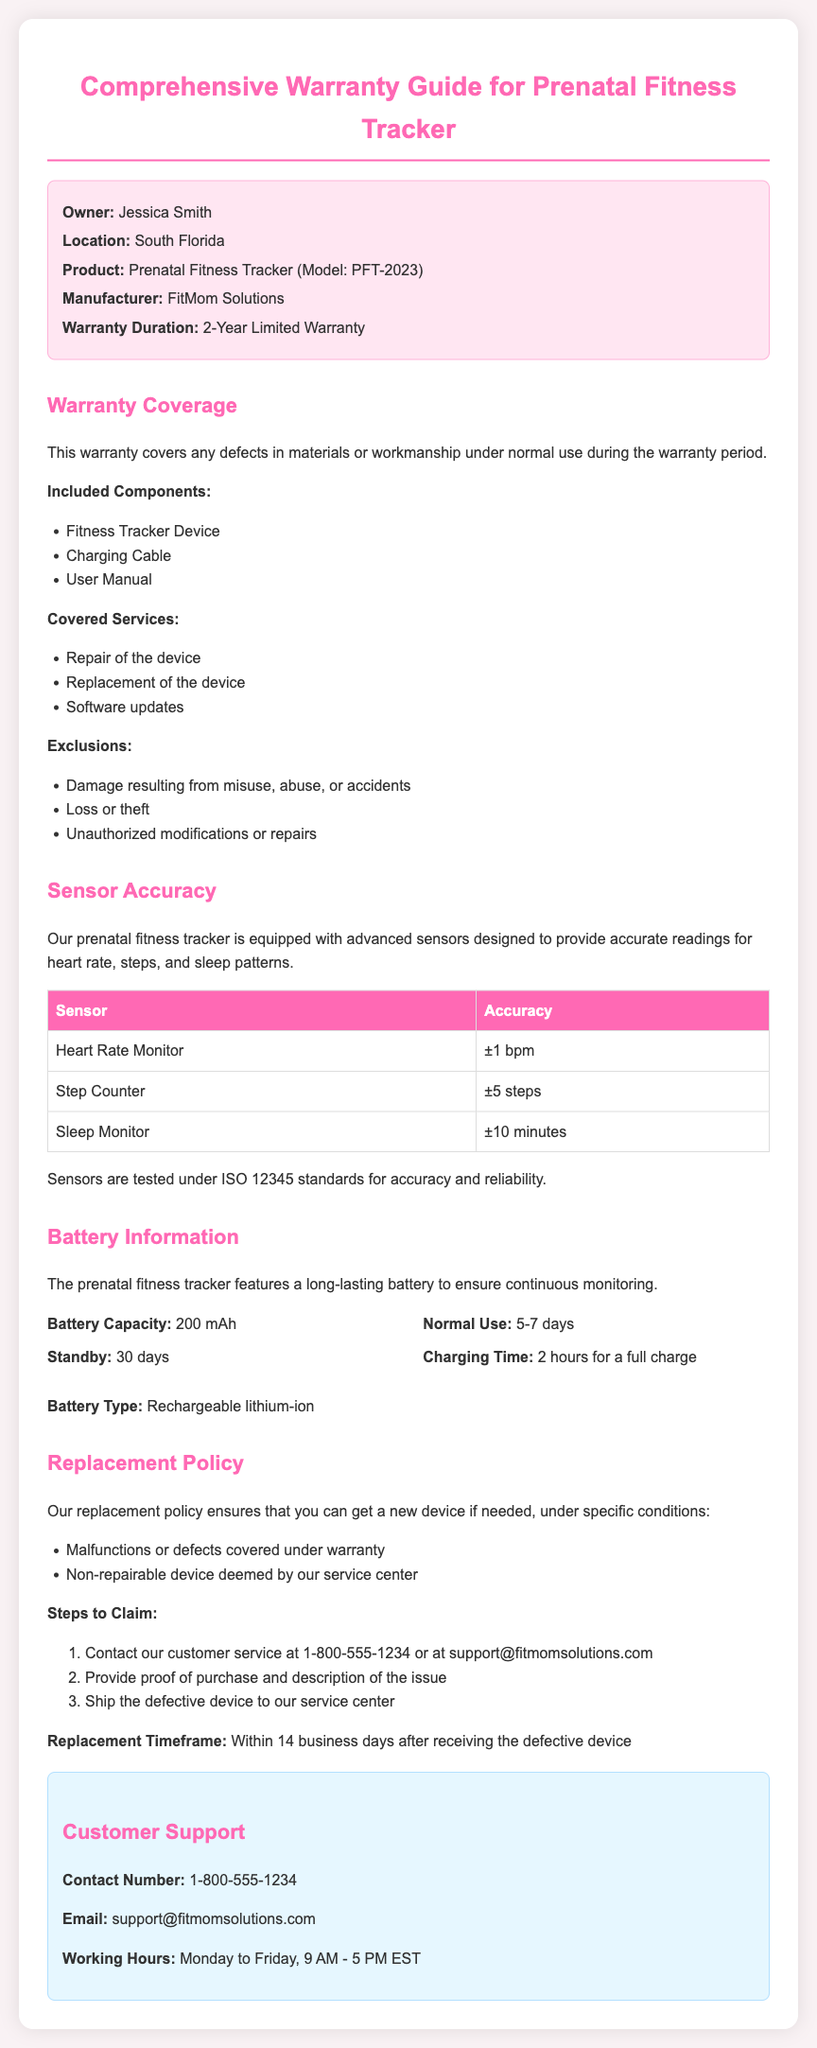What is the warranty duration? The warranty duration is stated clearly in the document as two years.
Answer: 2-Year Limited Warranty What is the battery capacity? The document specifies the battery capacity for the prenatal fitness tracker.
Answer: 200 mAh What is the accuracy of the heart rate monitor? The accuracy for the heart rate monitor is provided in the sensor accuracy table.
Answer: ±1 bpm What must be provided to claim a replacement? The document lists the required information for claiming a replacement.
Answer: Proof of purchase What are the normal use days for the battery? The battery information section indicates how long the device lasts under normal use.
Answer: 5-7 days What services are covered under the warranty? The covered services are listed in the warranty coverage section of the document.
Answer: Repair of the device What is the replacement timeframe? The timeframe for replacement after sending in a defective device is mentioned in the document.
Answer: Within 14 business days What is the customer's service contact number? The customer support section provides the contact number for assistance.
Answer: 1-800-555-1234 What type of battery does the device use? The battery type is specified in the battery information section.
Answer: Rechargeable lithium-ion 